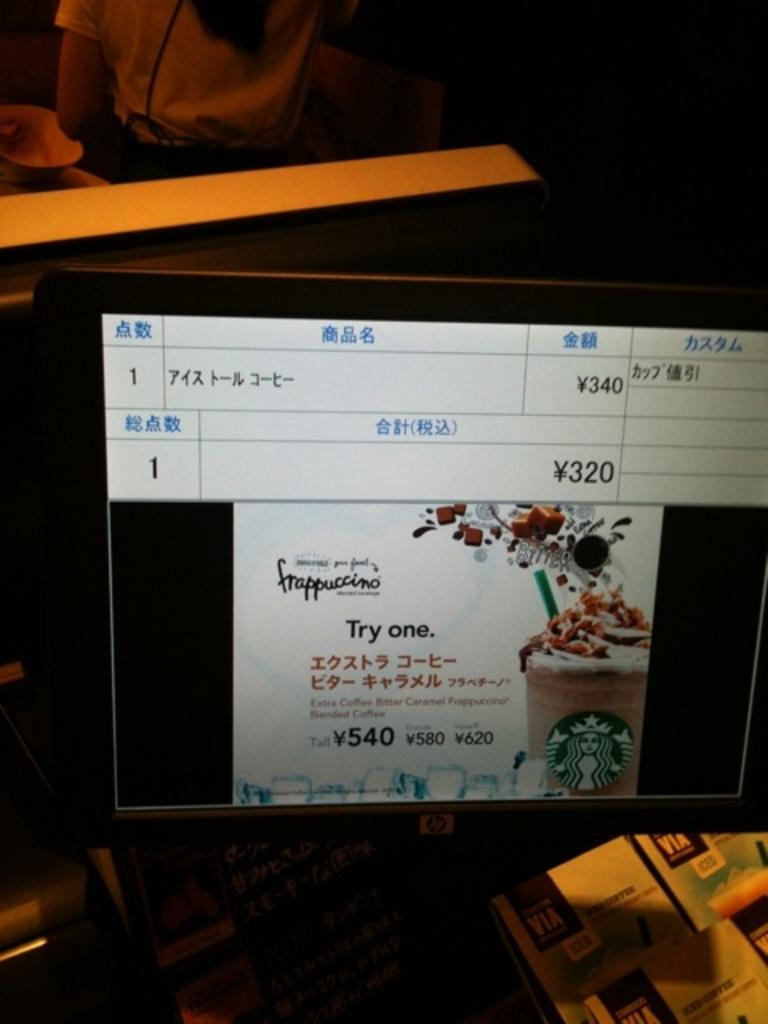<image>
Share a concise interpretation of the image provided. The hp screen displays an ad for Starbuck's frappuccino, urging you to "Try one". 